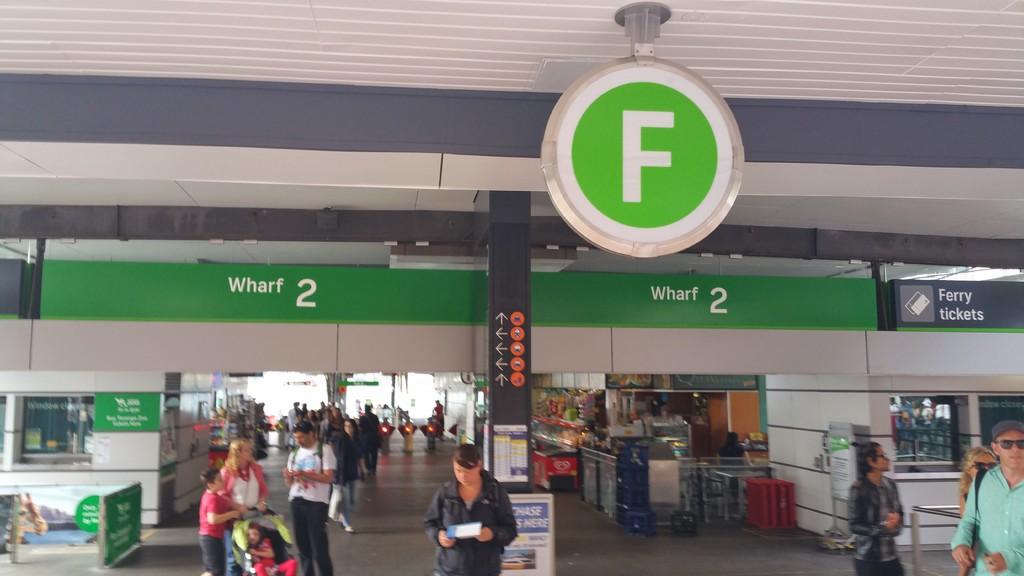How many wharfs are seen?
Keep it short and to the point. 2. What kind of tickets can you buy?
Offer a terse response. Ferry. 